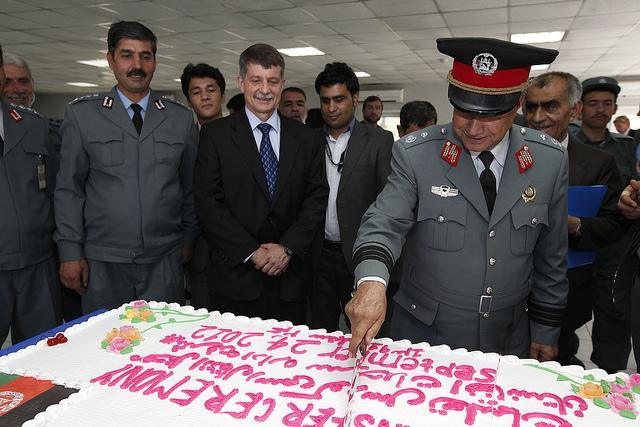Why is the man reaching towards the cake?

Choices:
A) to smash
B) to decorate
C) to wipe
D) to cut to cut 